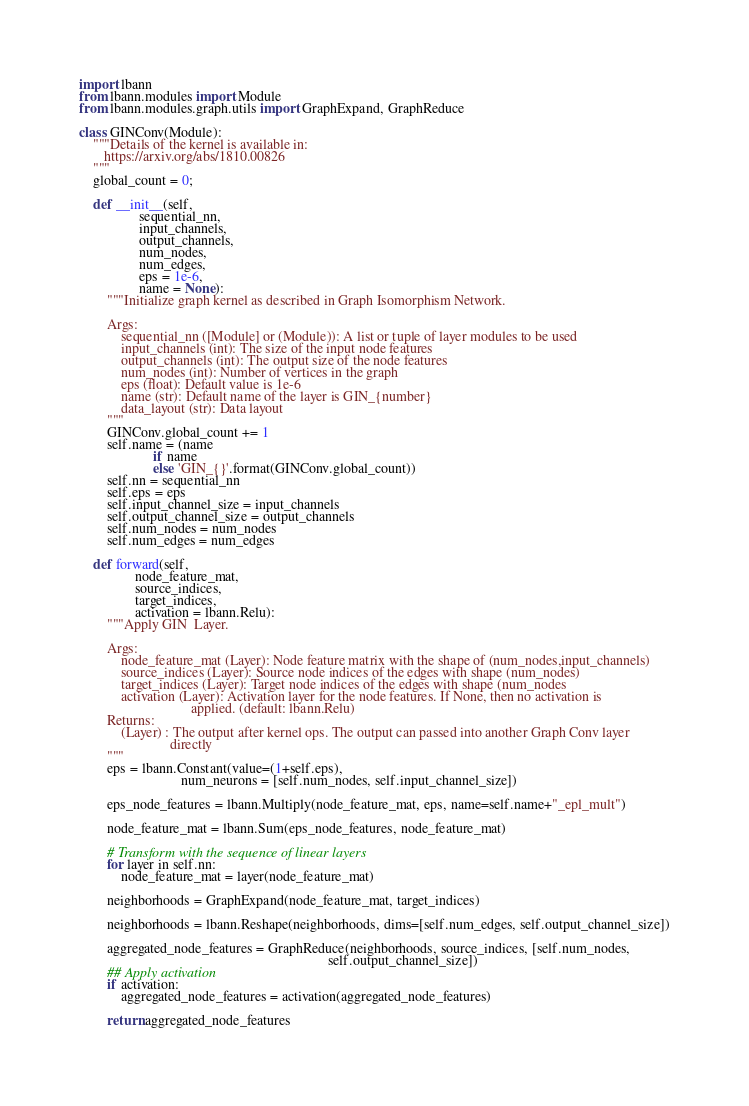<code> <loc_0><loc_0><loc_500><loc_500><_Python_>import lbann
from lbann.modules import Module
from lbann.modules.graph.utils import GraphExpand, GraphReduce

class GINConv(Module):
    """Details of the kernel is available in:
       https://arxiv.org/abs/1810.00826
    """
    global_count = 0;

    def __init__(self,
                 sequential_nn,
                 input_channels,
                 output_channels,
                 num_nodes,
                 num_edges,
                 eps = 1e-6,
                 name = None):
        """Initialize graph kernel as described in Graph Isomorphism Network.

        Args:
            sequential_nn ([Module] or (Module)): A list or tuple of layer modules to be used
            input_channels (int): The size of the input node features
            output_channels (int): The output size of the node features
            num_nodes (int): Number of vertices in the graph
            eps (float): Default value is 1e-6
            name (str): Default name of the layer is GIN_{number}
            data_layout (str): Data layout
        """
        GINConv.global_count += 1
        self.name = (name
                     if name
                     else 'GIN_{}'.format(GINConv.global_count))
        self.nn = sequential_nn
        self.eps = eps
        self.input_channel_size = input_channels
        self.output_channel_size = output_channels
        self.num_nodes = num_nodes
        self.num_edges = num_edges

    def forward(self,
                node_feature_mat,
                source_indices,
                target_indices,
                activation = lbann.Relu):
        """Apply GIN  Layer.

        Args:
            node_feature_mat (Layer): Node feature matrix with the shape of (num_nodes,input_channels)
            source_indices (Layer): Source node indices of the edges with shape (num_nodes)
            target_indices (Layer): Target node indices of the edges with shape (num_nodes
            activation (Layer): Activation layer for the node features. If None, then no activation is
                                applied. (default: lbann.Relu)
        Returns:
            (Layer) : The output after kernel ops. The output can passed into another Graph Conv layer
                          directly
        """
        eps = lbann.Constant(value=(1+self.eps),
                             num_neurons = [self.num_nodes, self.input_channel_size])

        eps_node_features = lbann.Multiply(node_feature_mat, eps, name=self.name+"_epl_mult")

        node_feature_mat = lbann.Sum(eps_node_features, node_feature_mat)

        # Transform with the sequence of linear layers
        for layer in self.nn:
            node_feature_mat = layer(node_feature_mat)

        neighborhoods = GraphExpand(node_feature_mat, target_indices)

        neighborhoods = lbann.Reshape(neighborhoods, dims=[self.num_edges, self.output_channel_size])

        aggregated_node_features = GraphReduce(neighborhoods, source_indices, [self.num_nodes,
                                                                       self.output_channel_size])
        ## Apply activation
        if activation:
            aggregated_node_features = activation(aggregated_node_features)

        return aggregated_node_features
</code> 